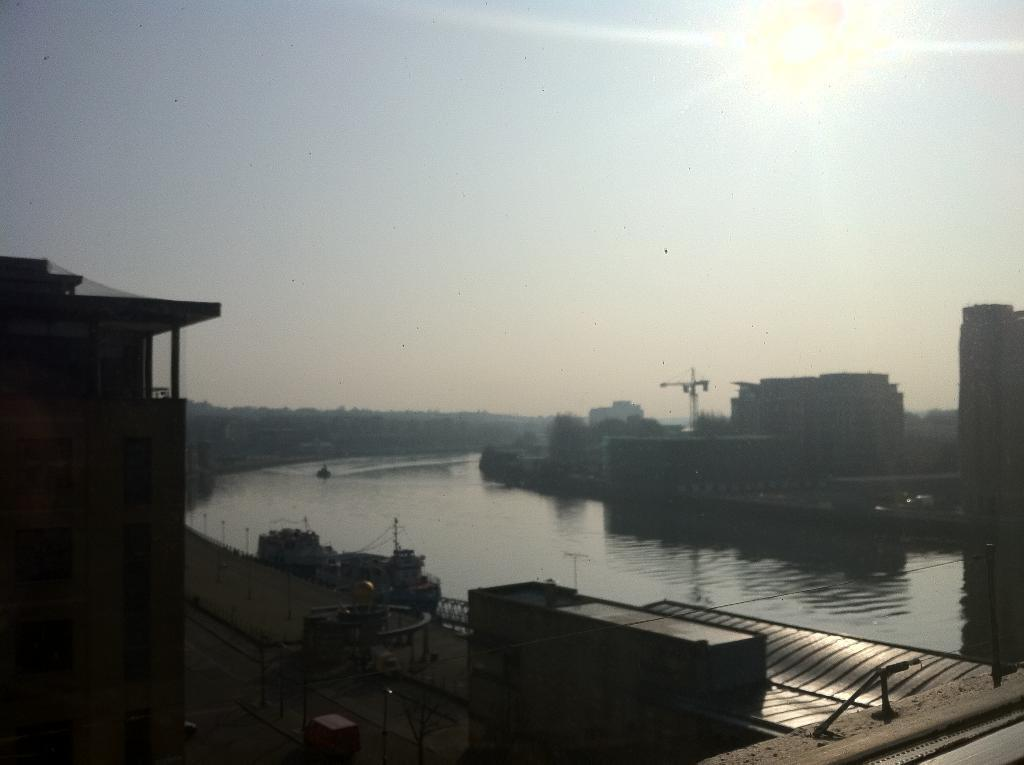What is visible in the image? Water is visible in the image. What can be seen on the left side of the image? There are buildings on the left side of the image. What can be seen on the right side of the image? There are buildings on the right side of the image. What is visible at the top of the image? The sun and the sky are visible at the top of the image. How many cats are sitting on the buildings in the image? There are no cats present in the image; it only features buildings, water, the sun, and the sky. What type of fuel is being used by the sun in the image? The image does not provide information about the sun's fuel source, as it is a representation of the sun and not a scientific illustration. 